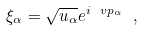Convert formula to latex. <formula><loc_0><loc_0><loc_500><loc_500>\xi _ { \alpha } = \sqrt { u _ { \alpha } } e ^ { i \ v p _ { \alpha } } \ ,</formula> 